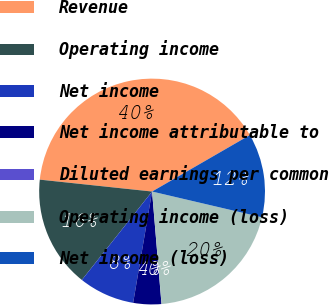<chart> <loc_0><loc_0><loc_500><loc_500><pie_chart><fcel>Revenue<fcel>Operating income<fcel>Net income<fcel>Net income attributable to<fcel>Diluted earnings per common<fcel>Operating income (loss)<fcel>Net income (loss)<nl><fcel>39.99%<fcel>16.0%<fcel>8.0%<fcel>4.01%<fcel>0.01%<fcel>20.0%<fcel>12.0%<nl></chart> 